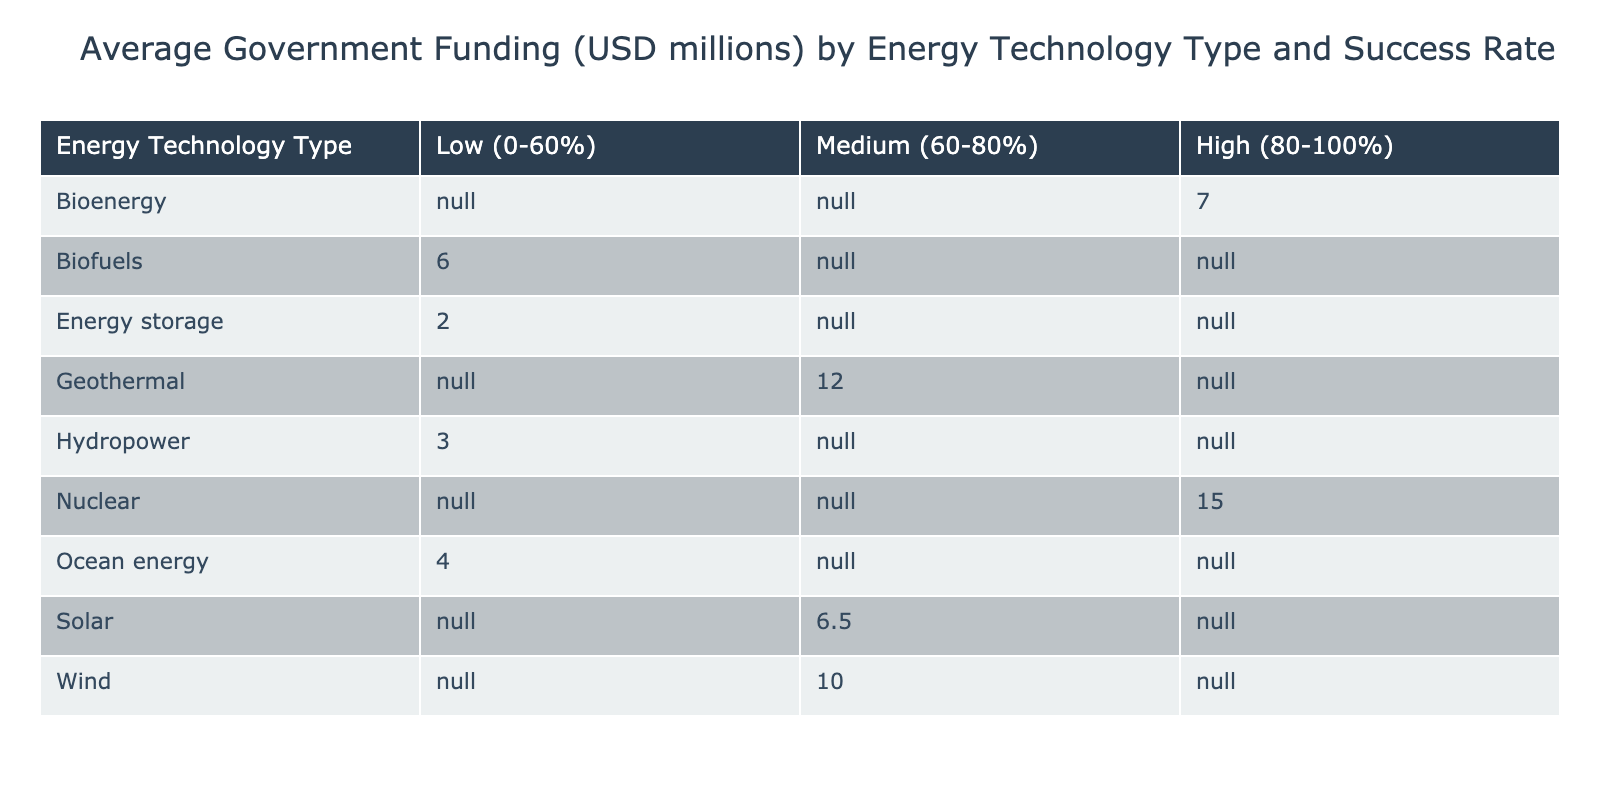What is the average government funding for companies in the 'High (80-100%)' success rate category? To find the average funding for startups in the 'High' category, we look at the respective funding for each technology type: RenewableTech Innovations (5), Cleantech Dynamics (7), PowerGenX (15). The sum of these is 5 + 7 + 15 = 27. Dividing by the number of companies (3) gives us 27/3 = 9.
Answer: 9 Which energy technology type has the lowest average government funding? By examining the table, the average funding for each energy technology type is as follows: Solar (6.5), Wind (10), Hydropower (3), Bioenergy (7), Ocean energy (4), Geothermal (12), Nuclear (15), Energy storage (2), Biofuels (6). The lowest average funding is for Energy storage at 2 million USD.
Answer: 2 Is there any energy technology type that has a success rate categorized as 'Low (0-60%)'? From the table data, the success rates below 60% are for HydroGen Systems (60%), WaveEnergy Corp (50%), and EcoBattery Solutions (55%). Since the cut-off for 'Low' includes up to 60%, HydroGen Systems is the only one not in this range, confirming that Ocean energy and Energy storage are classified as 'Low' rates due to WaveEnergy Corp and EcoBattery Solutions.
Answer: Yes What is the total government funding for technology types classified under 'Medium (60-80%)'? From the analysis of the 'Medium' category, the respective funding contributions are HydroGen Systems (3), SolarGrid Enterprises (8), Thermal Efficiency Inc (12), and NextGen Fuel (6). Adding these amounts gives us 3 + 8 + 12 + 6 = 29 million USD.
Answer: 29 Which technology type under 'Low (0-60%)' category has the highest government funding? Inspecting the 'Low' category, we find that the only funding amounts are HydroGen Systems (3), WaveEnergy Corp (4), and EcoBattery Solutions (2). The highest among these is WaveEnergy Corp at 4 million USD.
Answer: 4 What is the success rate for the type with the highest average funding? The type with the highest average funding is Nuclear at 15 million USD with a corresponding success rate of 85%. Therefore, the success rate for this category is 85%.
Answer: 85 Does every energy technology type with 'High (80-100%)' success rate also have government funding higher than 10 million USD? The technologies in the 'High' category are RenewableTech Innovations (5), Cleantech Dynamics (7), and PowerGenX (15). The only ones with funding less than 10 million are RenewableTech Innovations and Cleantech Dynamics. Thus, not every technology in this category exceeds 10 million USD in funding.
Answer: No Which success rate category has the highest total government funding? To find this, we need to sum the funding for each success rate category: 'Low' (3 + 4 + 2 = 9), 'Medium' (3 + 8 + 12 + 6 = 29), 'High' (5 + 7 + 15 = 27). The total for 'Medium' is 29 million USD, making it the category with the highest total funding.
Answer: Medium 